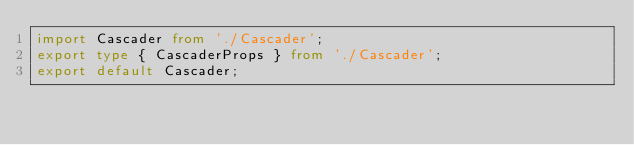<code> <loc_0><loc_0><loc_500><loc_500><_TypeScript_>import Cascader from './Cascader';
export type { CascaderProps } from './Cascader';
export default Cascader;
</code> 